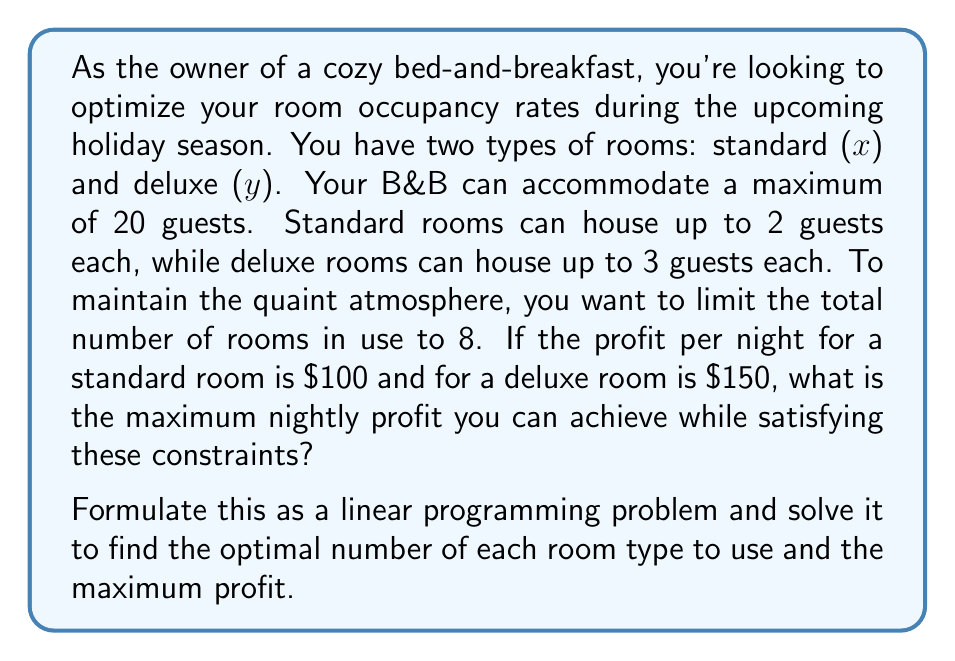Provide a solution to this math problem. Let's approach this step-by-step:

1) First, we need to define our variables:
   $x$ = number of standard rooms
   $y$ = number of deluxe rooms

2) Now, let's formulate our objective function:
   Maximize $Z = 100x + 150y$ (profit function)

3) Next, we'll define our constraints:
   a) Total guests: $2x + 3y \leq 20$
   b) Total rooms: $x + y \leq 8$
   c) Non-negativity: $x \geq 0, y \geq 0$

4) Our linear programming problem is now:
   Maximize $Z = 100x + 150y$
   Subject to:
   $2x + 3y \leq 20$
   $x + y \leq 8$
   $x \geq 0, y \geq 0$

5) To solve this, we'll use the graphical method:

   [asy]
   import graph;
   size(200);
   xaxis("x", 0, 10, Arrow);
   yaxis("y", 0, 10, Arrow);
   draw((0,20/3)--(10,0), blue);
   draw((0,8)--(8,0), red);
   fill((0,0)--(8,0)--(5,3)--(0,20/3)--cycle, lightgray);
   dot((5,3));
   label("(5,3)", (5,3), NE);
   [/asy]

6) The feasible region is the shaded area. The corner points are (0,0), (8,0), (5,3), and (0,20/3).

7) Evaluating the objective function at these points:
   (0,0): $Z = 0$
   (8,0): $Z = 800$
   (5,3): $Z = 950$
   (0,20/3): $Z = 1000$ (not an integer solution)

8) The optimal integer solution is at (5,3), meaning 5 standard rooms and 3 deluxe rooms.

9) The maximum profit is: $100(5) + 150(3) = 500 + 450 = 950$
Answer: The optimal solution is to use 5 standard rooms and 3 deluxe rooms, achieving a maximum nightly profit of $950. 